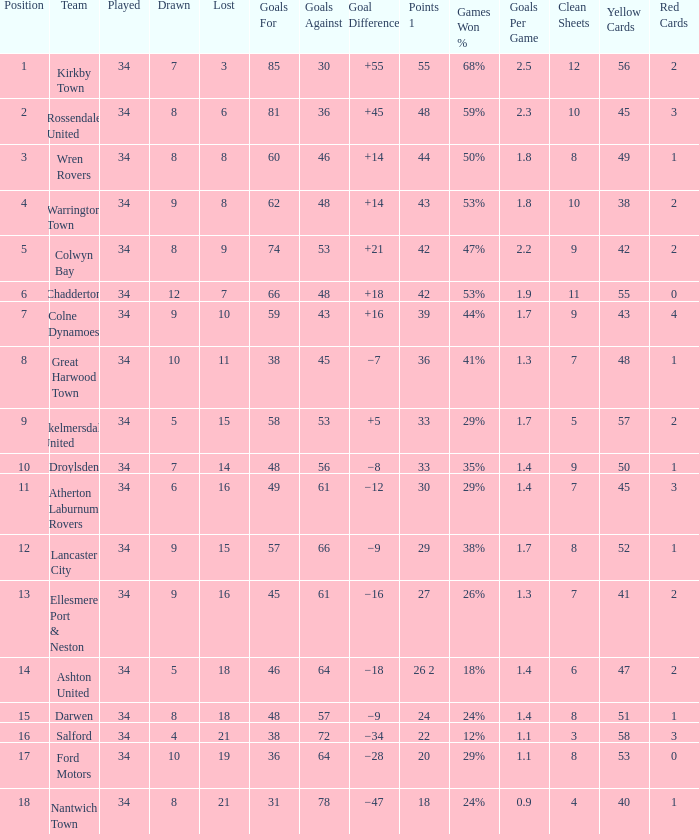What is the total number of positions when there are more than 48 goals against, 1 of 29 points are played, and less than 34 games have been played? 0.0. 